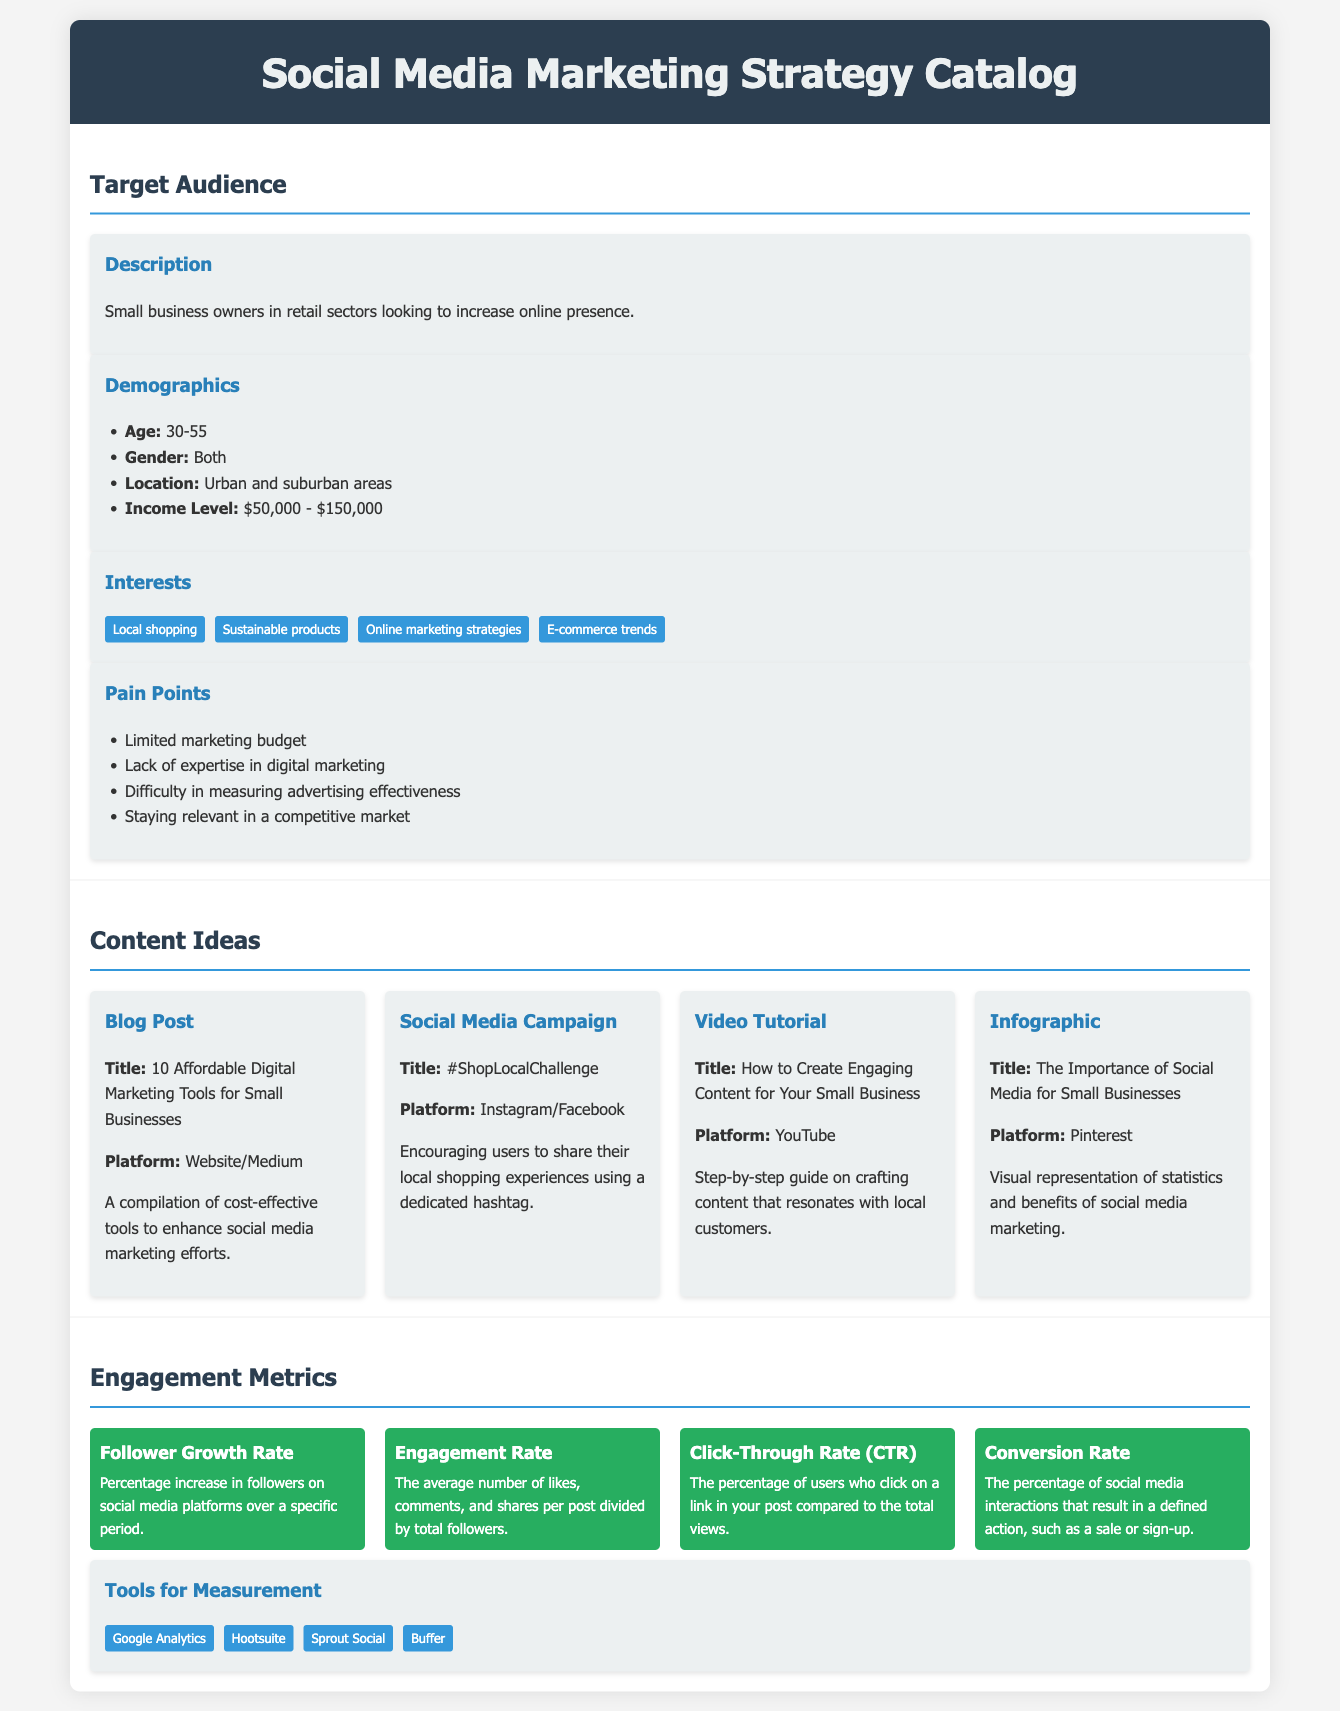what is the age range of the target audience? The age range of the target audience is specified in the demographics section of the document.
Answer: 30-55 what are the interests of the target audience? The interests of the target audience are listed in the interests section of the document.
Answer: Local shopping, Sustainable products, Online marketing strategies, E-commerce trends what is one pain point of the target audience? Pain points of the target audience are mentioned in the pain points section of the document.
Answer: Limited marketing budget what is the title of the social media campaign suggested? The title of the suggested social media campaign can be found in the content ideas section.
Answer: #ShopLocalChallenge which platform is recommended for video tutorials? The recommended platform for video tutorials is mentioned in the content ideas section.
Answer: YouTube what is the engagement rate? The engagement rate is a specific metric explained in the engagement metrics section of the document.
Answer: The average number of likes, comments, and shares per post divided by total followers how many tools for measurement are listed? The number of tools for measurement can be counted from the tools for measurement section of the document.
Answer: 4 what type of content does the infographic represent? The type of content represented by the infographic is specified in the content ideas section.
Answer: The Importance of Social Media for Small Businesses which demographic is targeted in terms of income level? The targeted demographic income level is listed in the demographics section.
Answer: $50,000 - $150,000 